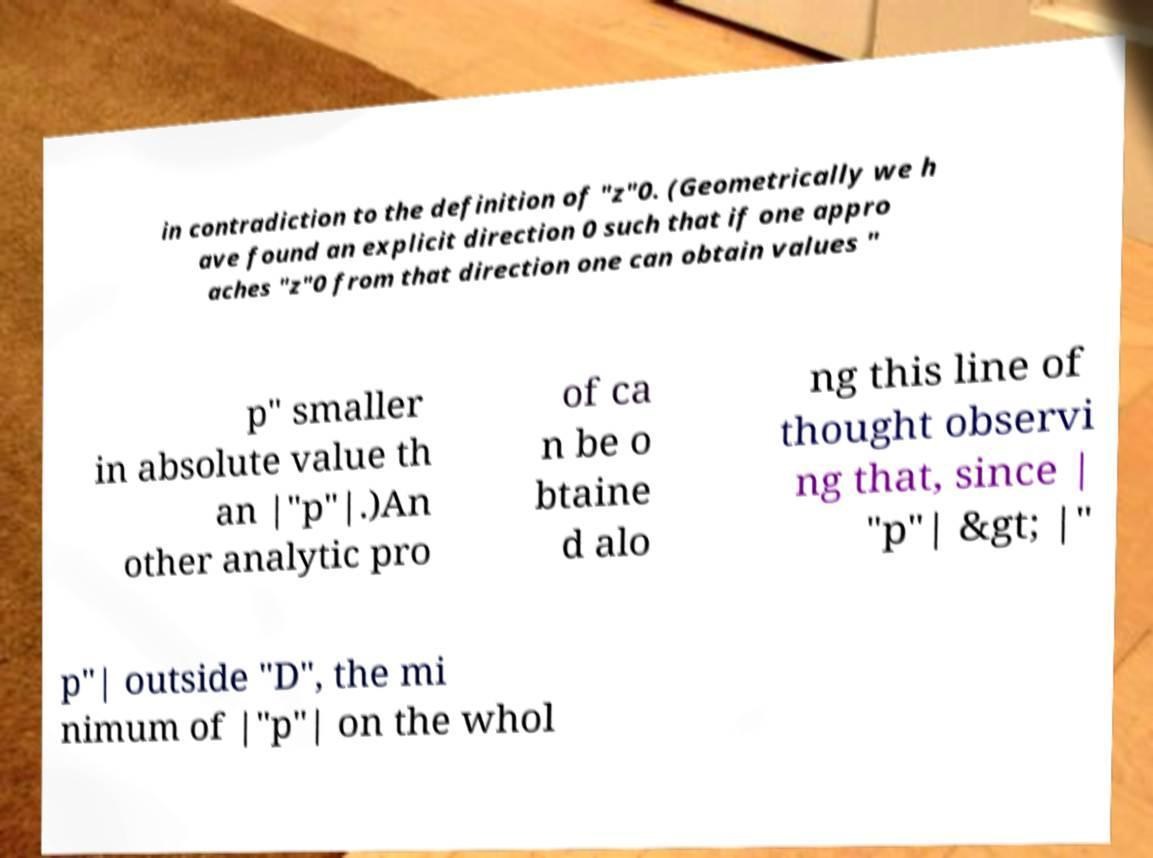There's text embedded in this image that I need extracted. Can you transcribe it verbatim? in contradiction to the definition of "z"0. (Geometrically we h ave found an explicit direction 0 such that if one appro aches "z"0 from that direction one can obtain values " p" smaller in absolute value th an |"p"|.)An other analytic pro of ca n be o btaine d alo ng this line of thought observi ng that, since | "p"| &gt; |" p"| outside "D", the mi nimum of |"p"| on the whol 